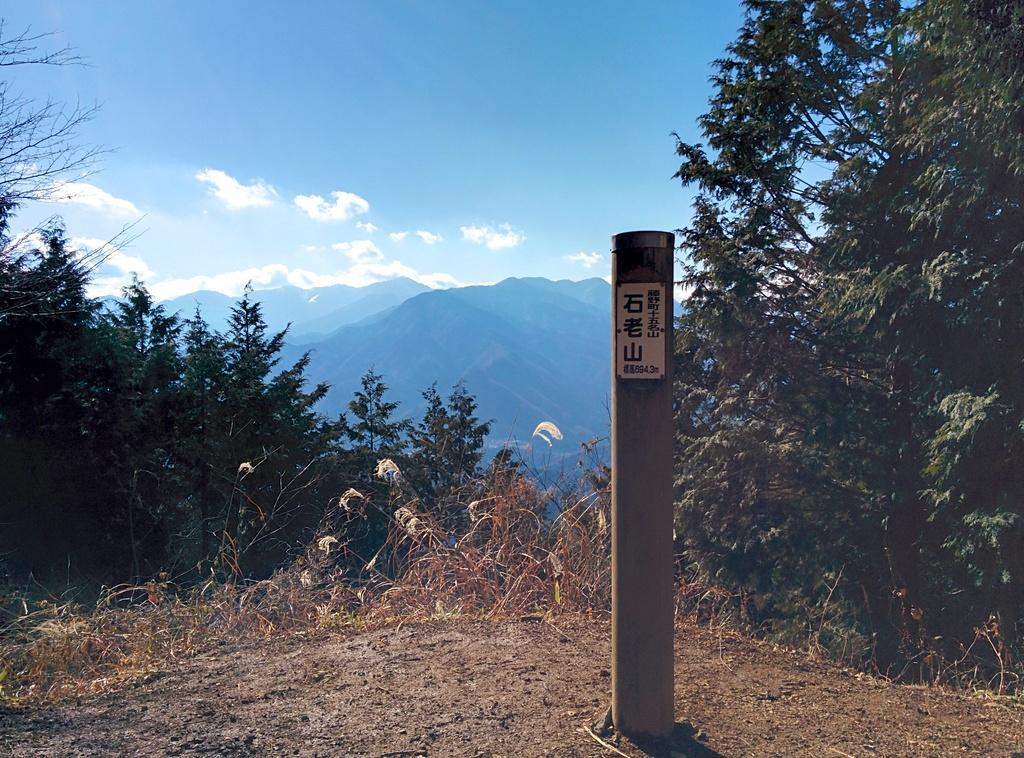What structure is located on the right side of the image? There is a pole on the right side of the image. What type of natural elements can be seen in the image? There are trees in the image. What can be seen in the distance in the image? There are hills visible in the background of the image. What is visible in the sky in the background of the image? There are clouds in the sky in the background of the image. What type of box is placed on the pole in the image? There is no box present on the pole in the image. What is the plate used for in the image? There is no plate present in the image. 